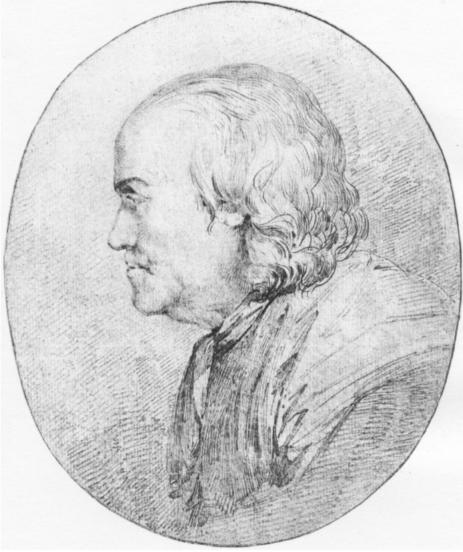Can you describe the artistic technique used in this sketch? The artist employed a detailed sketching technique that involves a fine gradation of shading and precise line work, typical of pencil portraits. The technique showcases an adept handling of chiaroscuro, the contrast between light and dark, to give depth and volume to the subject's features. Every stroke in the sketch is deliberate, highlighting the texture of the clothing and the structure of the face, and suggesting a meticulous attention to realism. This technique not only captures the physical characteristics of the subject but also conveys a nuanced portrayal of his demeanor. 